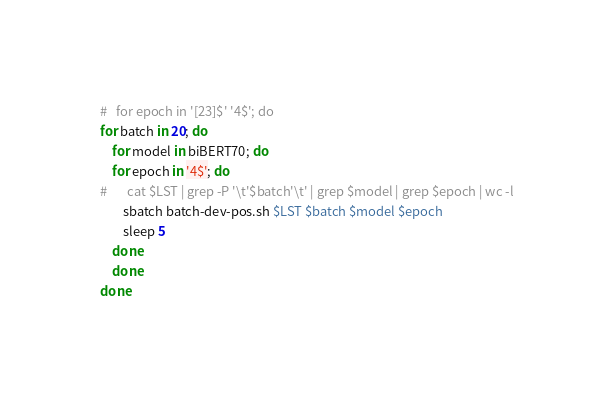<code> <loc_0><loc_0><loc_500><loc_500><_Bash_>#	for epoch in '[23]$' '4$'; do
for batch in 20; do
    for model in biBERT70; do
	for epoch in '4$'; do
#	    cat $LST | grep -P '\t'$batch'\t' | grep $model | grep $epoch | wc -l
	    sbatch batch-dev-pos.sh $LST $batch $model $epoch
	    sleep 5
	done
    done
done
</code> 